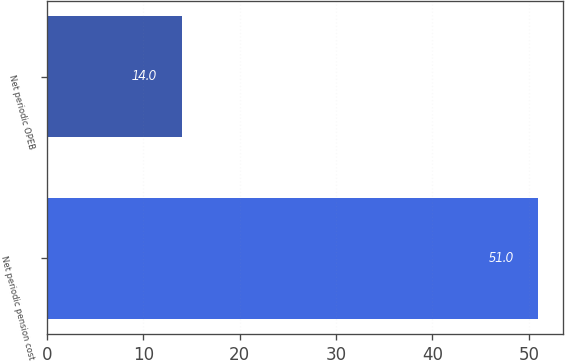Convert chart. <chart><loc_0><loc_0><loc_500><loc_500><bar_chart><fcel>Net periodic pension cost<fcel>Net periodic OPEB<nl><fcel>51<fcel>14<nl></chart> 